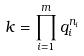Convert formula to latex. <formula><loc_0><loc_0><loc_500><loc_500>k = \prod _ { i = 1 } ^ { m } q _ { i } ^ { n _ { i } }</formula> 